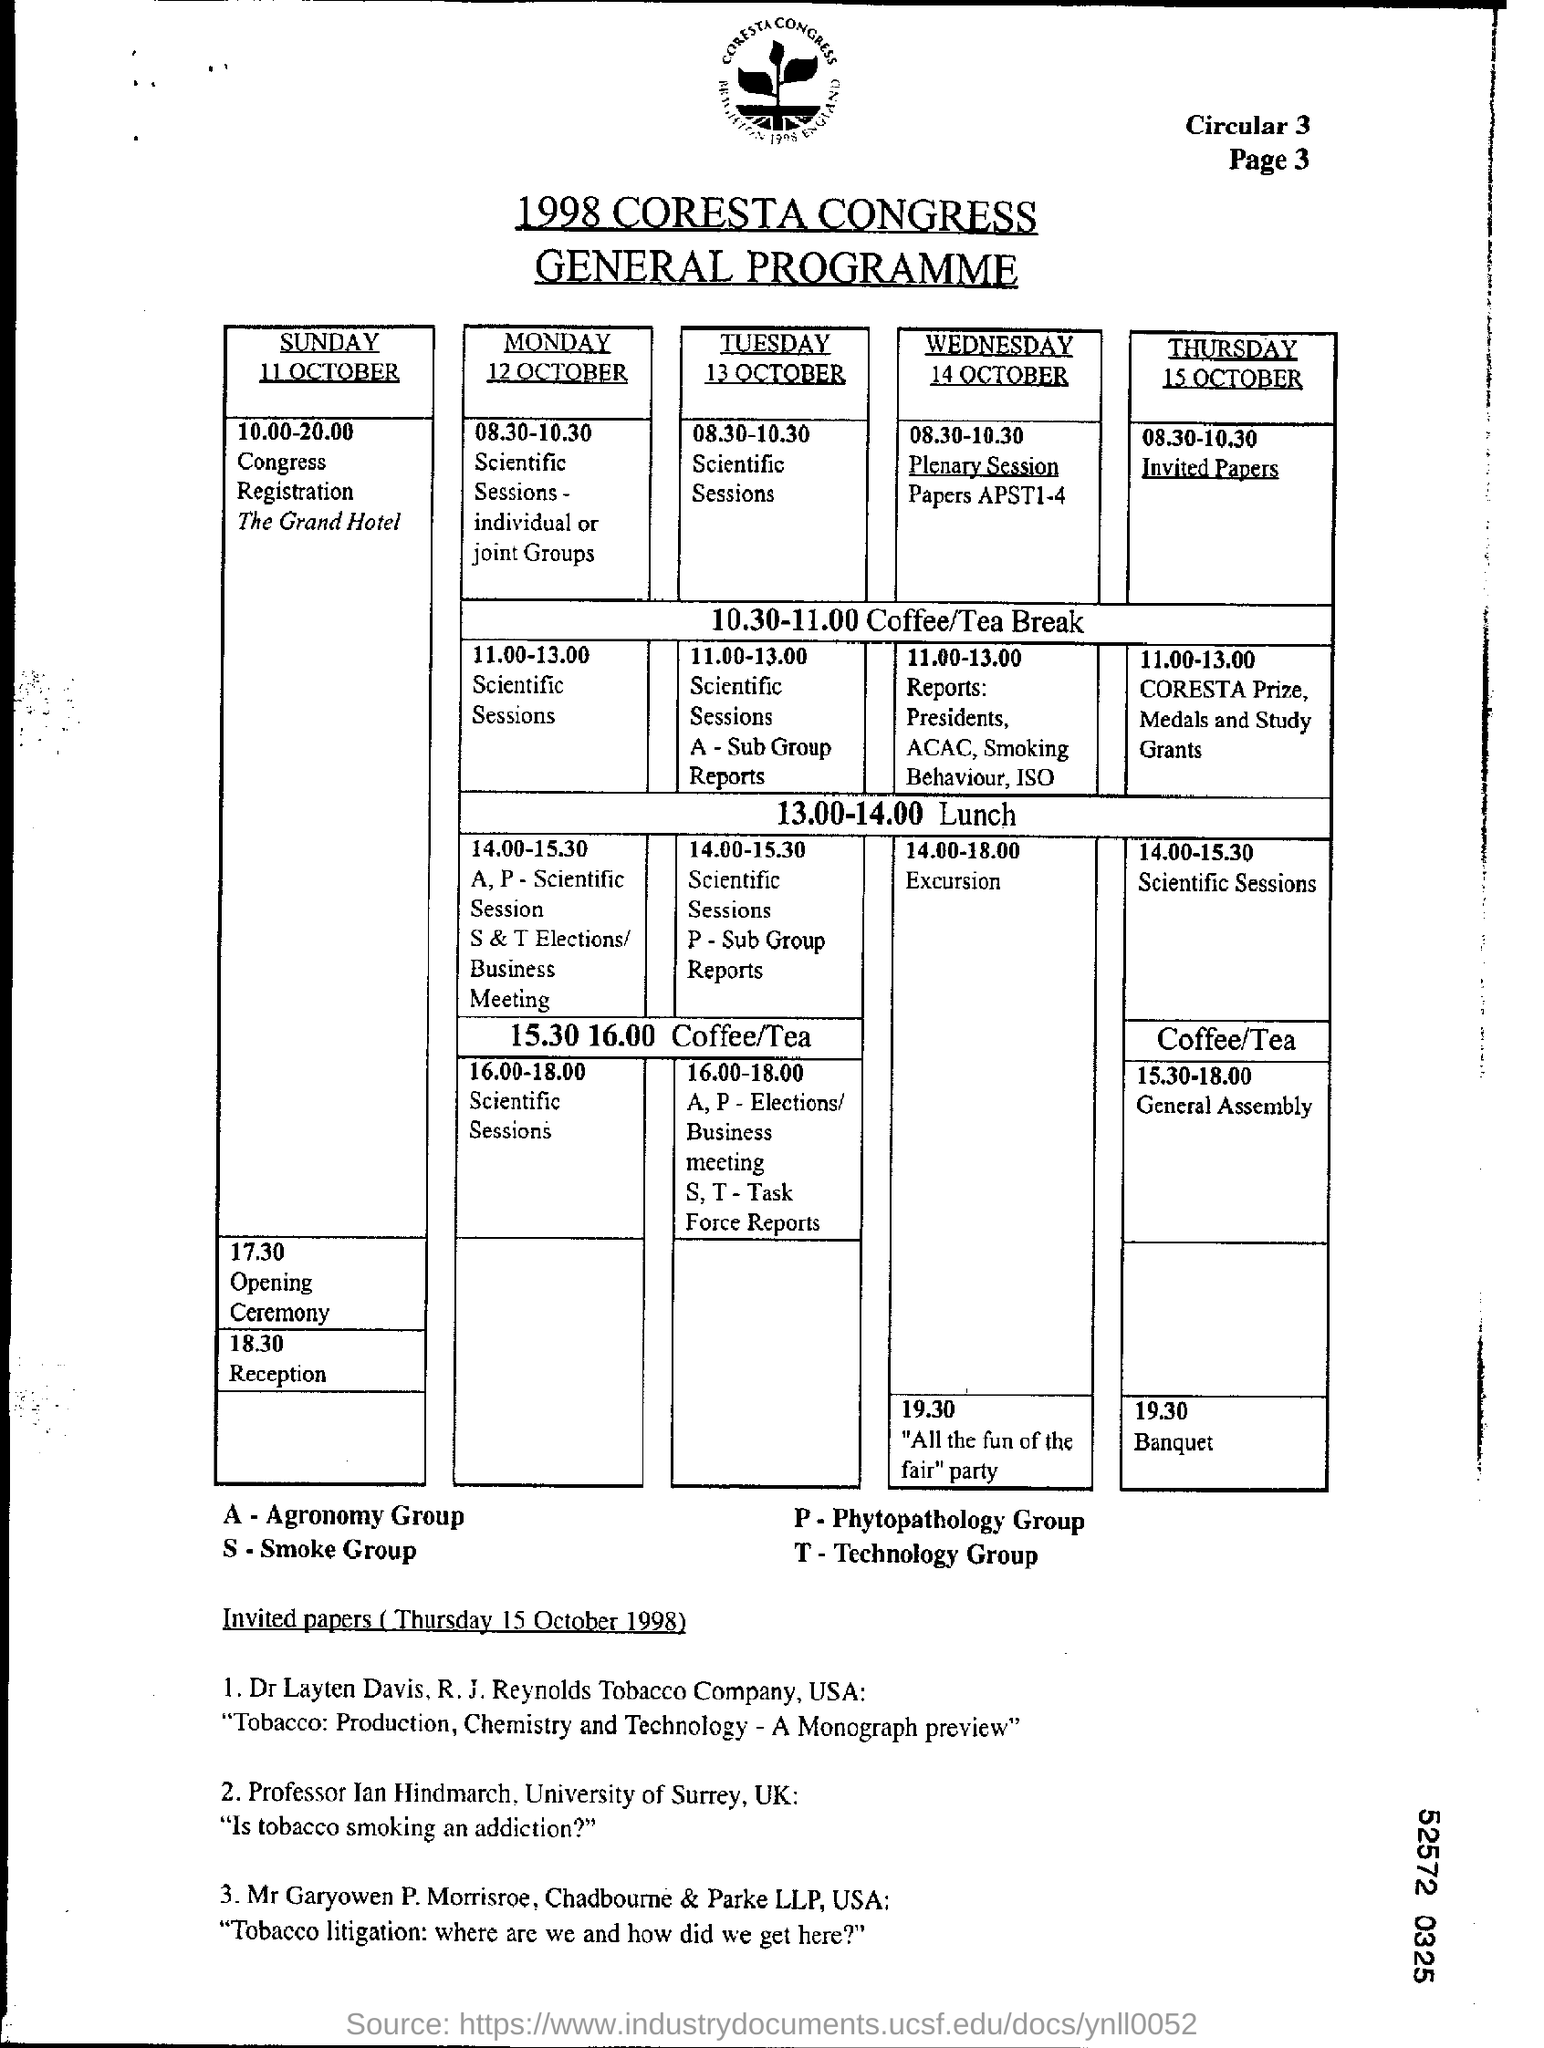Point out several critical features in this image. The letter "A" in the table represents the Agronomy Group, which is one of the four groups of crops included in the study. The term "S" in the table represents "Smoke Group. The abbreviation "T" in the table represents the Technology Group. The abbreviation "P" in the table refers to the Phytopathology Group. 